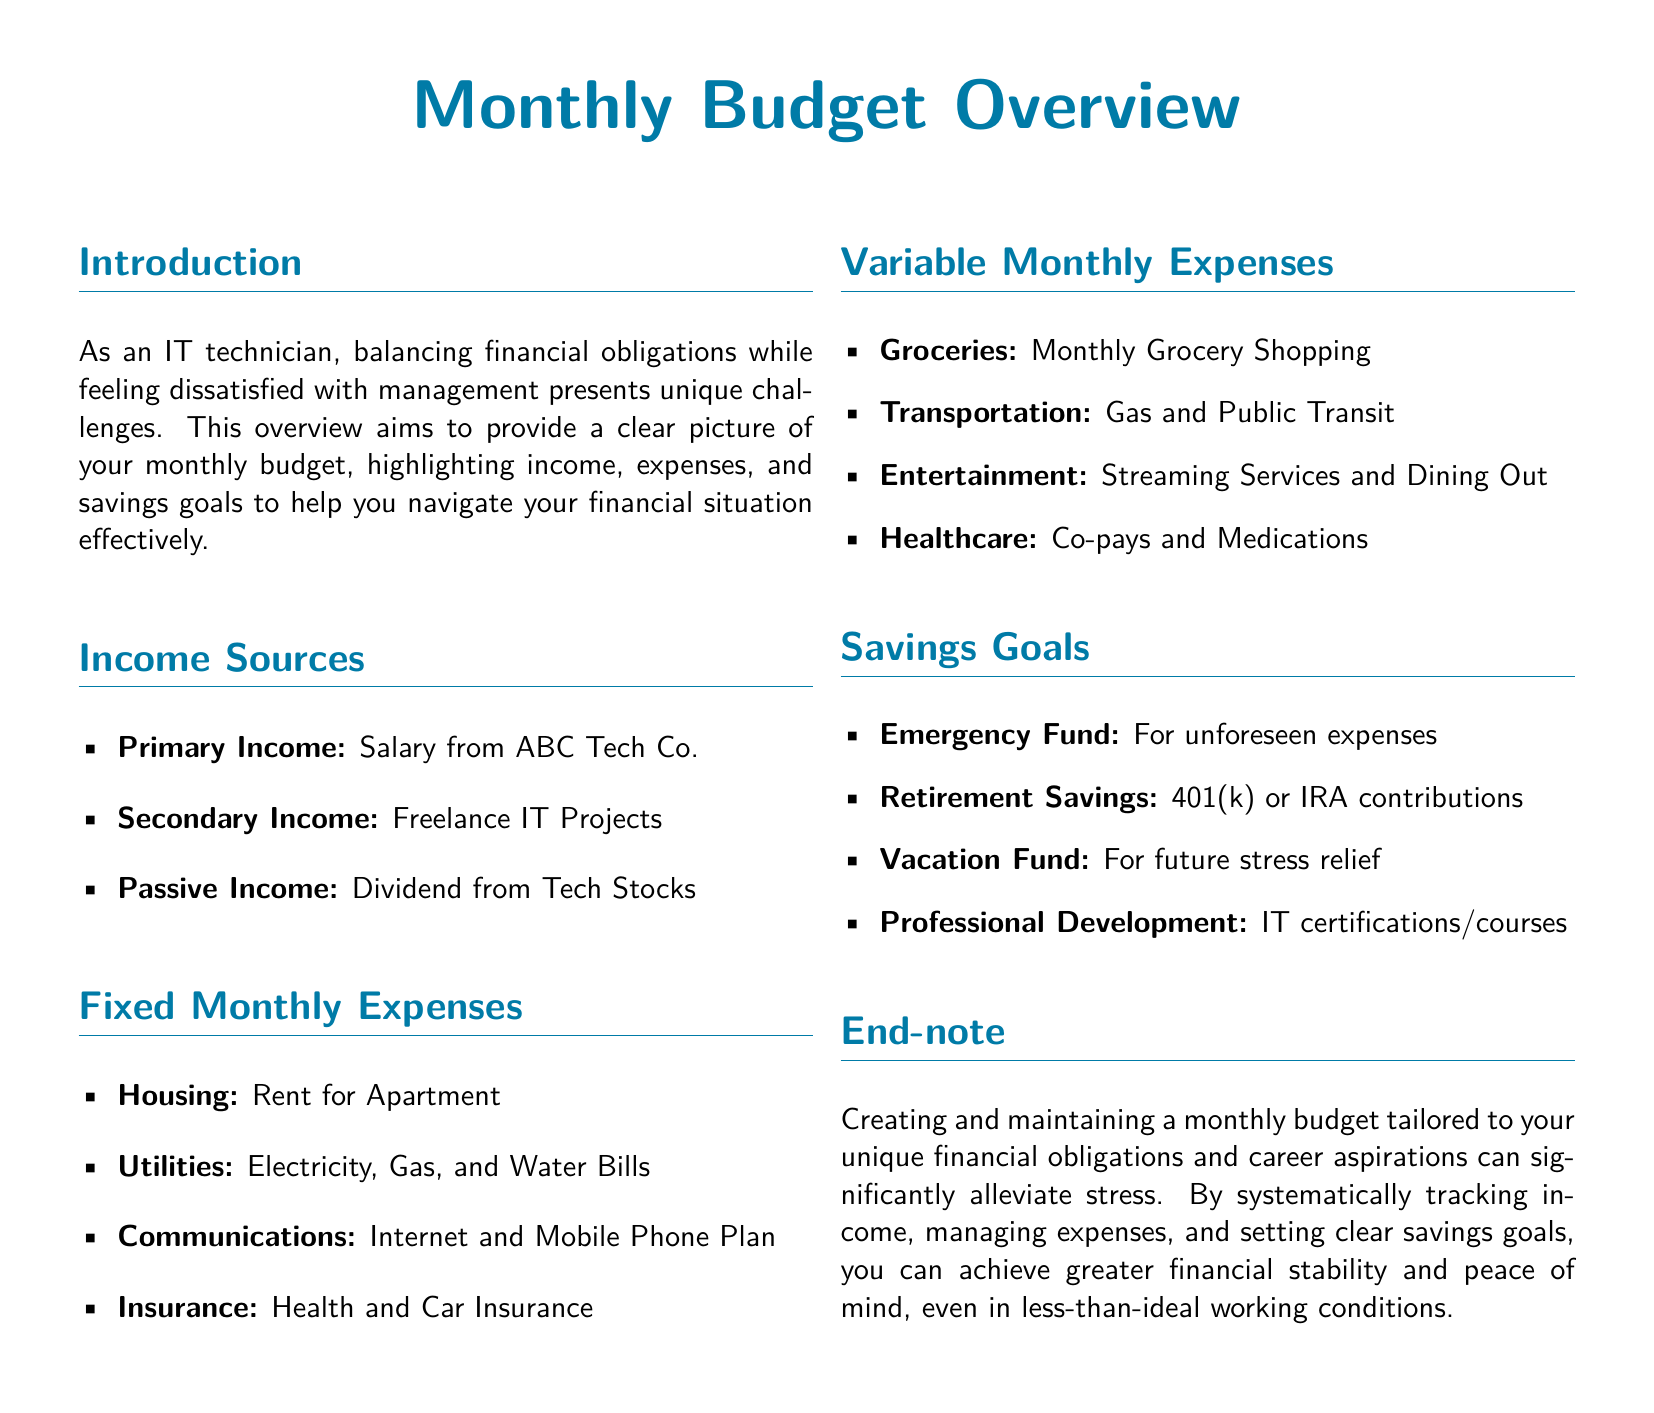what are the primary income sources? The primary income sources include salary from ABC Tech Co., freelance IT projects, and dividends from tech stocks.
Answer: Salary from ABC Tech Co., Freelance IT Projects, Dividend from Tech Stocks what type of expenses are there? The document categorizes expenses into fixed monthly expenses and variable monthly expenses.
Answer: Fixed and Variable what savings goal is set for unforeseen expenses? The savings goal set for unforeseen expenses is specifically identified as the emergency fund.
Answer: Emergency Fund what is one fixed monthly expense listed? Among the fixed monthly expenses listed, rent for apartment is specified.
Answer: Rent for Apartment how many savings goals are mentioned in the document? The document lists four savings goals for the reader to consider.
Answer: Four which utilities are included in fixed expenses? Fixed monthly expenses for utilities encompass electricity, gas, and water bills.
Answer: Electricity, Gas, Water Bills what is the primary reason provided for creating a budget? The primary reason for creating a budget is to achieve greater financial stability and peace of mind.
Answer: Financial stability and peace of mind what can be funded for future stress relief? The vacation fund is explicitly mentioned as a goal for future stress relief.
Answer: Vacation Fund what type of communication expenses are included? The document specifies internet and mobile phone plan as part of communication expenses.
Answer: Internet and Mobile Phone Plan 